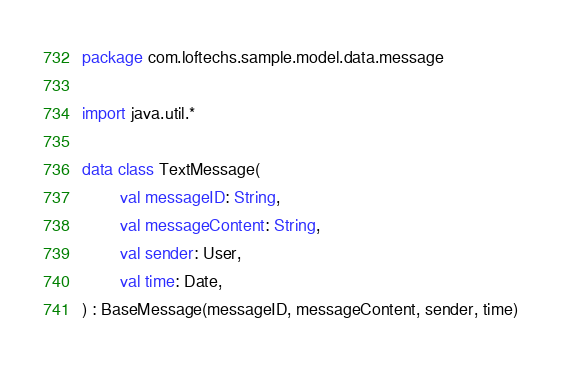Convert code to text. <code><loc_0><loc_0><loc_500><loc_500><_Kotlin_>package com.loftechs.sample.model.data.message

import java.util.*

data class TextMessage(
        val messageID: String,
        val messageContent: String,
        val sender: User,
        val time: Date,
) : BaseMessage(messageID, messageContent, sender, time)</code> 